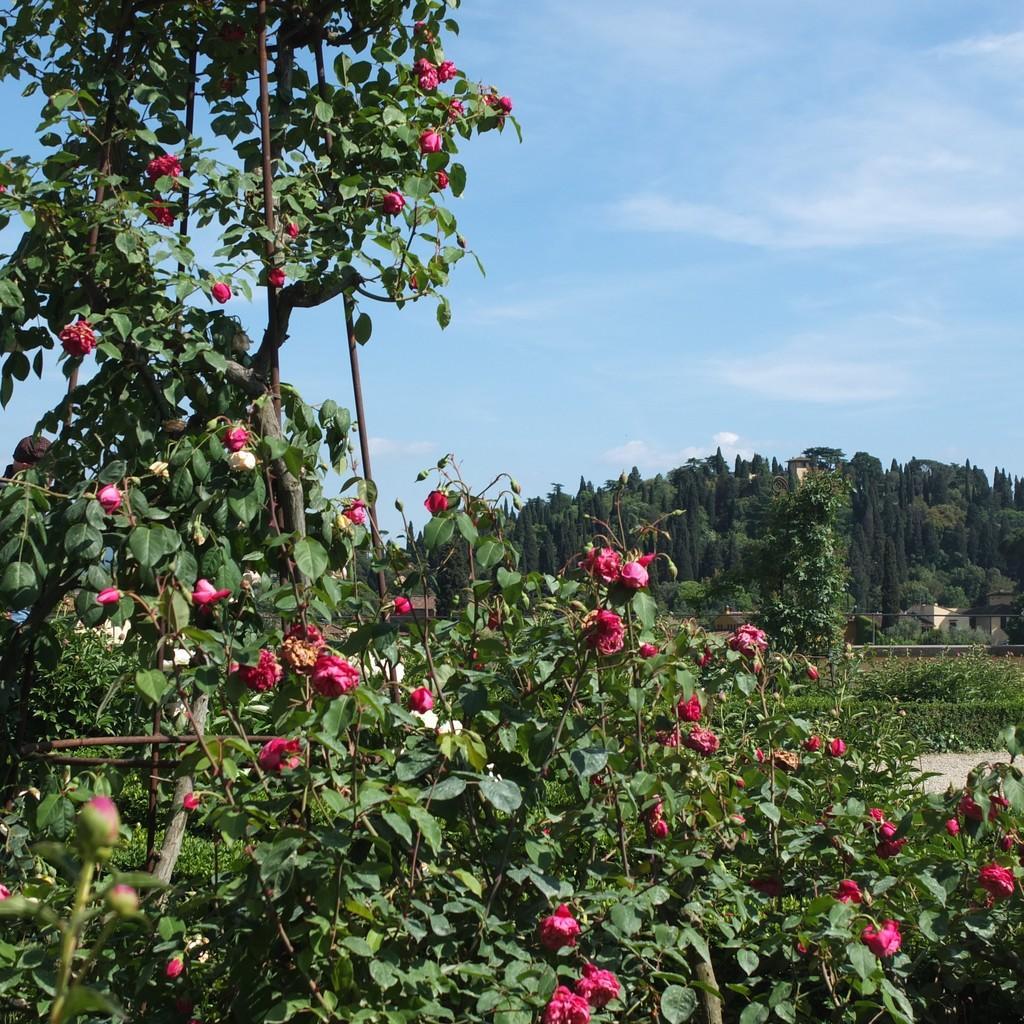Could you give a brief overview of what you see in this image? In the center of the image we can see plants with flowers. In the background, we can see the sky, clouds, trees, plants and a few other objects. 